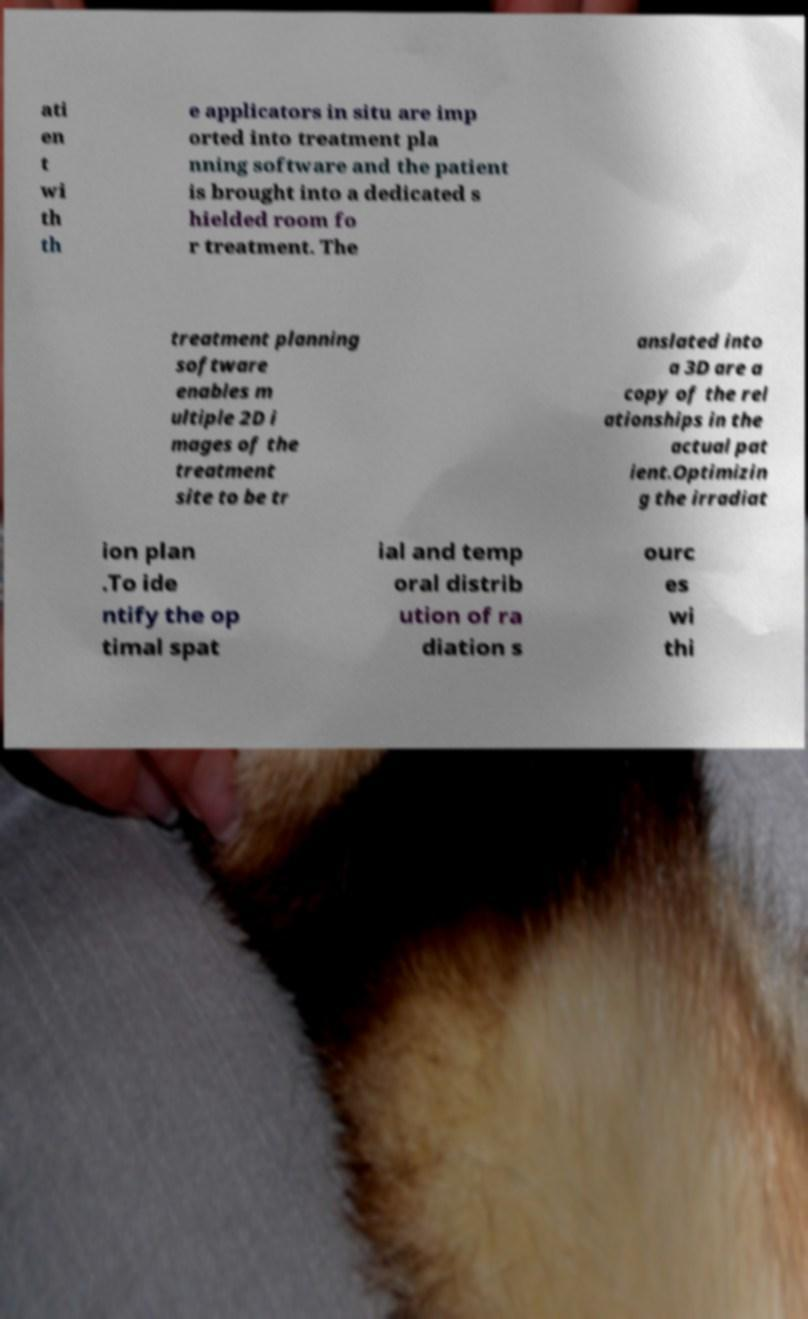Please read and relay the text visible in this image. What does it say? ati en t wi th th e applicators in situ are imp orted into treatment pla nning software and the patient is brought into a dedicated s hielded room fo r treatment. The treatment planning software enables m ultiple 2D i mages of the treatment site to be tr anslated into a 3D are a copy of the rel ationships in the actual pat ient.Optimizin g the irradiat ion plan .To ide ntify the op timal spat ial and temp oral distrib ution of ra diation s ourc es wi thi 